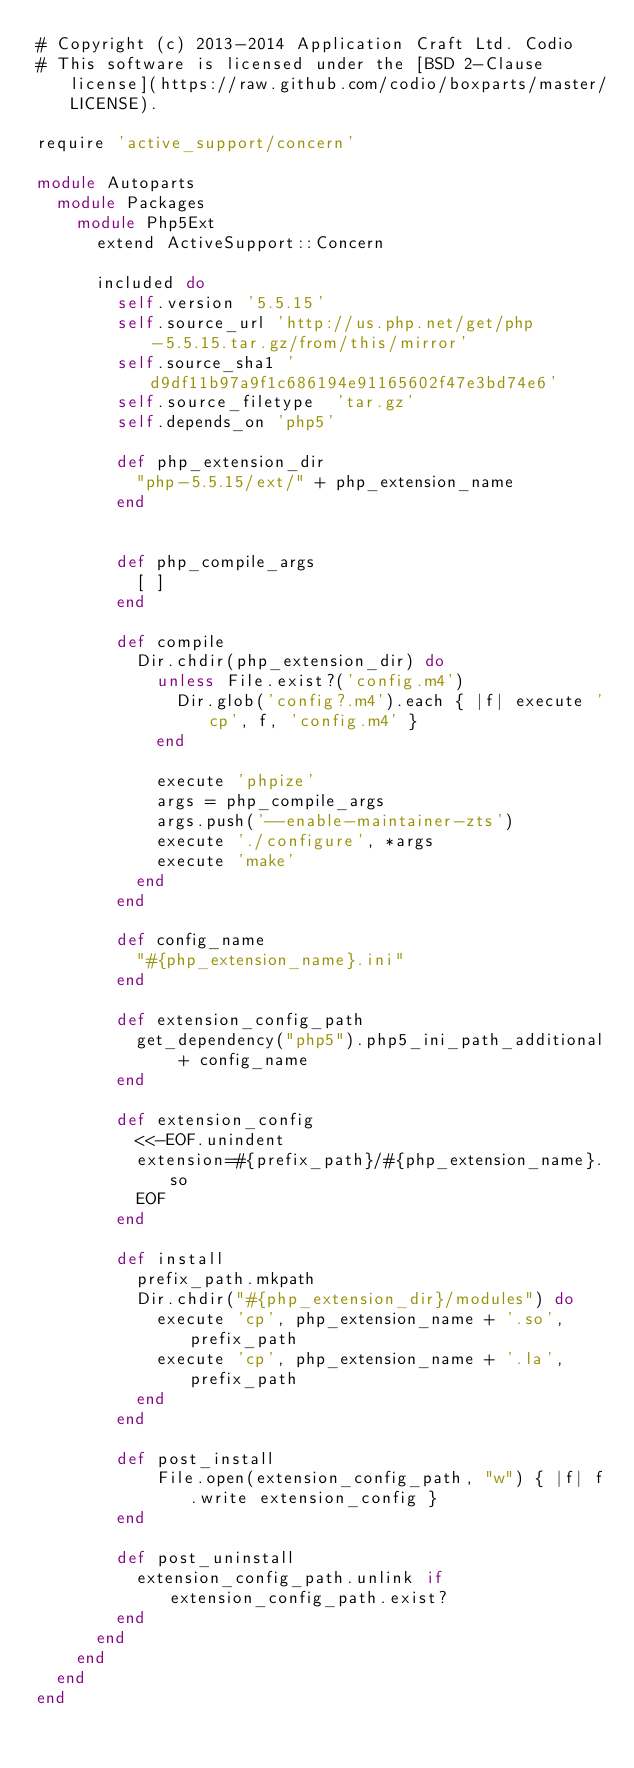Convert code to text. <code><loc_0><loc_0><loc_500><loc_500><_Ruby_># Copyright (c) 2013-2014 Application Craft Ltd. Codio
# This software is licensed under the [BSD 2-Clause license](https://raw.github.com/codio/boxparts/master/LICENSE).

require 'active_support/concern'

module Autoparts
  module Packages
    module Php5Ext
      extend ActiveSupport::Concern

      included do
        self.version '5.5.15'
        self.source_url 'http://us.php.net/get/php-5.5.15.tar.gz/from/this/mirror'
        self.source_sha1 'd9df11b97a9f1c686194e91165602f47e3bd74e6'
        self.source_filetype  'tar.gz'
        self.depends_on 'php5'

        def php_extension_dir
          "php-5.5.15/ext/" + php_extension_name
        end


        def php_compile_args
          [ ]
        end

        def compile
          Dir.chdir(php_extension_dir) do
            unless File.exist?('config.m4')
              Dir.glob('config?.m4').each { |f| execute 'cp', f, 'config.m4' }
            end

            execute 'phpize'
            args = php_compile_args
            args.push('--enable-maintainer-zts')
            execute './configure', *args
            execute 'make'
          end
        end

        def config_name
          "#{php_extension_name}.ini"
        end

        def extension_config_path
          get_dependency("php5").php5_ini_path_additional + config_name
        end

        def extension_config
          <<-EOF.unindent
          extension=#{prefix_path}/#{php_extension_name}.so
          EOF
        end

        def install
          prefix_path.mkpath
          Dir.chdir("#{php_extension_dir}/modules") do
            execute 'cp', php_extension_name + '.so', prefix_path
            execute 'cp', php_extension_name + '.la', prefix_path
          end
        end

        def post_install
            File.open(extension_config_path, "w") { |f| f.write extension_config }
        end

        def post_uninstall
          extension_config_path.unlink if extension_config_path.exist?
        end
      end
    end
  end
end
</code> 